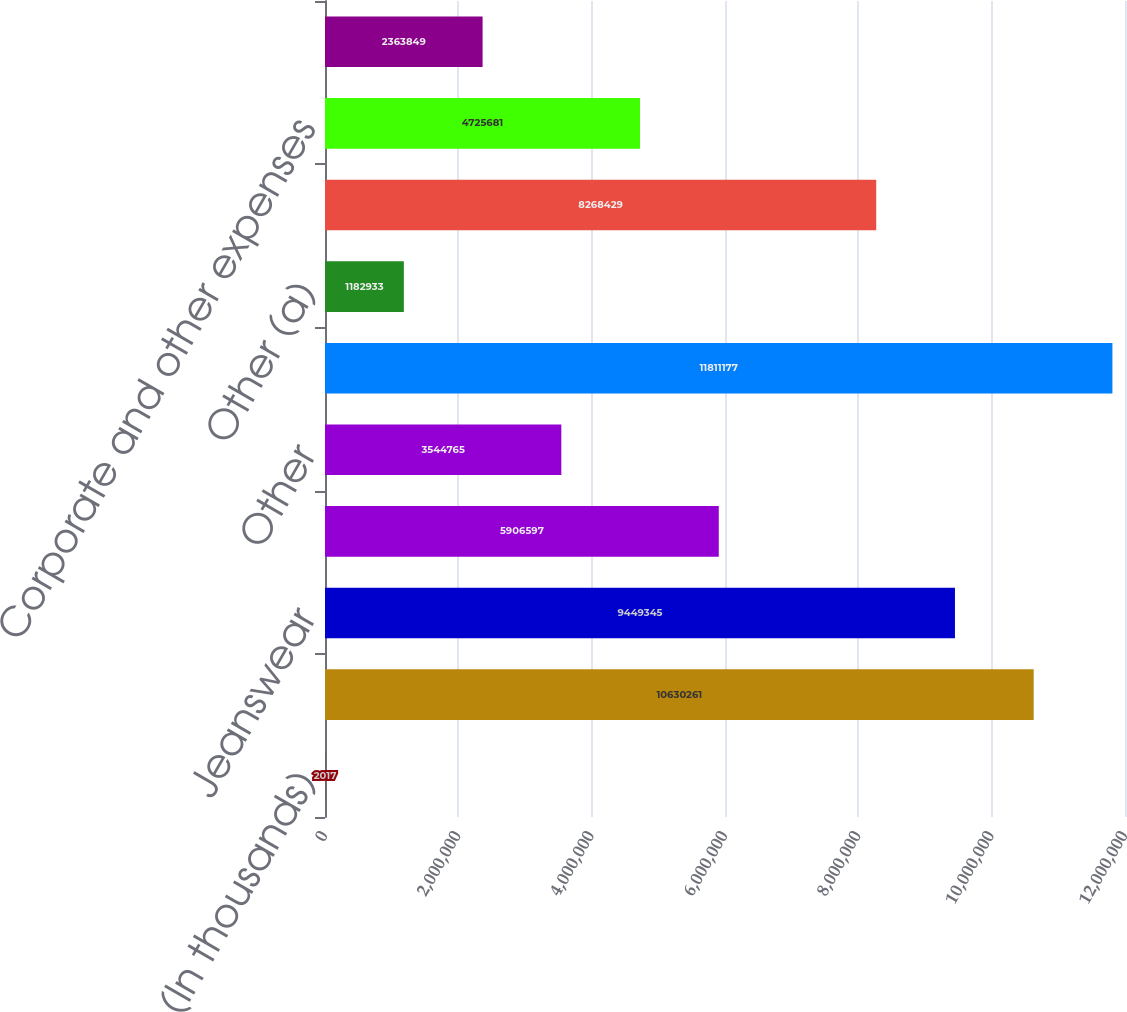Convert chart to OTSL. <chart><loc_0><loc_0><loc_500><loc_500><bar_chart><fcel>(In thousands)<fcel>Outdoor & Action Sports<fcel>Jeanswear<fcel>Imagewear<fcel>Other<fcel>Total coalition revenues<fcel>Other (a)<fcel>Total coalition profit<fcel>Corporate and other expenses<fcel>Interest expense net (e)<nl><fcel>2017<fcel>1.06303e+07<fcel>9.44934e+06<fcel>5.9066e+06<fcel>3.54476e+06<fcel>1.18112e+07<fcel>1.18293e+06<fcel>8.26843e+06<fcel>4.72568e+06<fcel>2.36385e+06<nl></chart> 